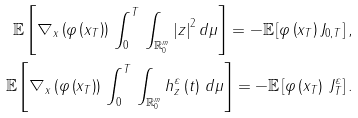Convert formula to latex. <formula><loc_0><loc_0><loc_500><loc_500>\mathbb { E } \left [ \nabla _ { x } \left ( \varphi \left ( x _ { T } \right ) \right ) \, \int _ { 0 } ^ { T } \, \int _ { \mathbb { R } _ { 0 } ^ { m } } \left | z \right | ^ { 2 } d \mu \right ] = - \mathbb { E } \left [ \varphi \left ( x _ { T } \right ) J _ { 0 , T } \right ] , \\ \mathbb { E } \left [ \nabla _ { x } \left ( \varphi \left ( x _ { T } \right ) \right ) \, \int _ { 0 } ^ { T } \, \int _ { \mathbb { R } _ { 0 } ^ { m } } h _ { z } ^ { \varepsilon } \left ( t \right ) \, d \mu \right ] = - \mathbb { E } \left [ \varphi \left ( x _ { T } \right ) \, J _ { T } ^ { \varepsilon } \right ] .</formula> 